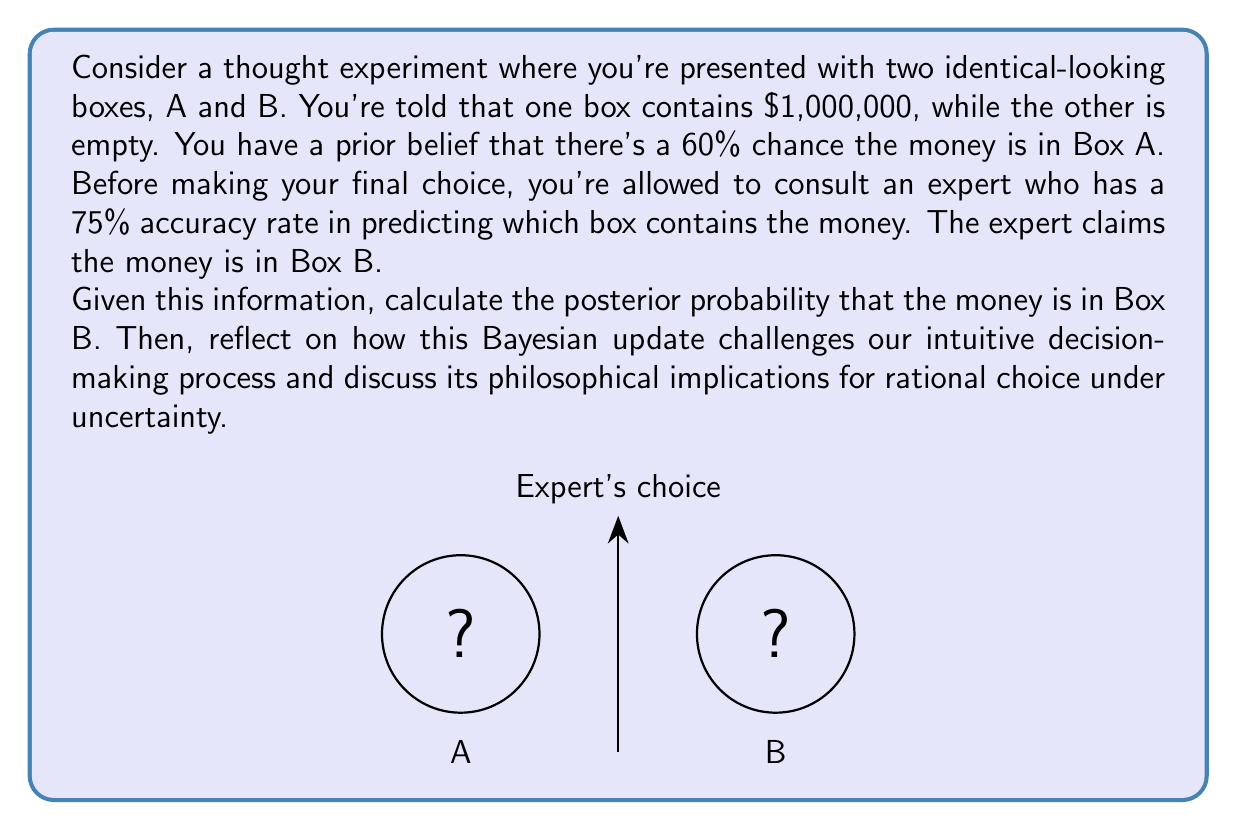Provide a solution to this math problem. Let's approach this problem step-by-step using Bayes' theorem:

1) Define our events:
   A: Money is in Box A
   B: Money is in Box B
   E: Expert claims money is in Box B

2) Given information:
   P(A) = 0.6 (prior probability for Box A)
   P(B) = 1 - P(A) = 0.4 (prior probability for Box B)
   P(E|B) = 0.75 (expert's accuracy when money is actually in B)
   P(E|A) = 1 - P(E|B) = 0.25 (expert's error rate when money is in A)

3) We want to calculate P(B|E) using Bayes' theorem:

   $$P(B|E) = \frac{P(E|B) \cdot P(B)}{P(E)}$$

4) Calculate P(E) using the law of total probability:
   $$P(E) = P(E|A) \cdot P(A) + P(E|B) \cdot P(B)$$
   $$P(E) = 0.25 \cdot 0.6 + 0.75 \cdot 0.4 = 0.15 + 0.3 = 0.45$$

5) Now we can calculate P(B|E):
   $$P(B|E) = \frac{0.75 \cdot 0.4}{0.45} = \frac{0.3}{0.45} = \frac{2}{3} \approx 0.6667$$

6) Philosophical implications:
   a) This result challenges our intuition. Despite our initial belief favoring Box A (60%), after considering the expert's opinion, the probability shifts to favor Box B (about 66.67%).
   
   b) It demonstrates how Bayesian reasoning can lead to counterintuitive yet rational decisions under uncertainty.
   
   c) This highlights the importance of considering new evidence and updating our beliefs accordingly, rather than stubbornly adhering to prior assumptions.
   
   d) It raises questions about the nature of rational decision-making: Should we always trust expert opinion? How do we weigh prior beliefs against new evidence?
   
   e) The process illustrates the subjectivity inherent in Bayesian reasoning, as different prior beliefs would lead to different posterior probabilities.
   
   f) It underscores the value of probabilistic thinking in decision-making, moving beyond simple "yes or no" choices to nuanced probability assessments.
   
   g) This approach to decision-making under uncertainty has far-reaching implications in fields such as science, medicine, law, and policy-making, where decisions often must be made with incomplete information.
Answer: P(B|E) ≈ 0.6667; Bayesian reasoning challenges intuitive decision-making by rationally incorporating new evidence to update prior beliefs, leading to potentially counterintuitive but more informed choices under uncertainty. 